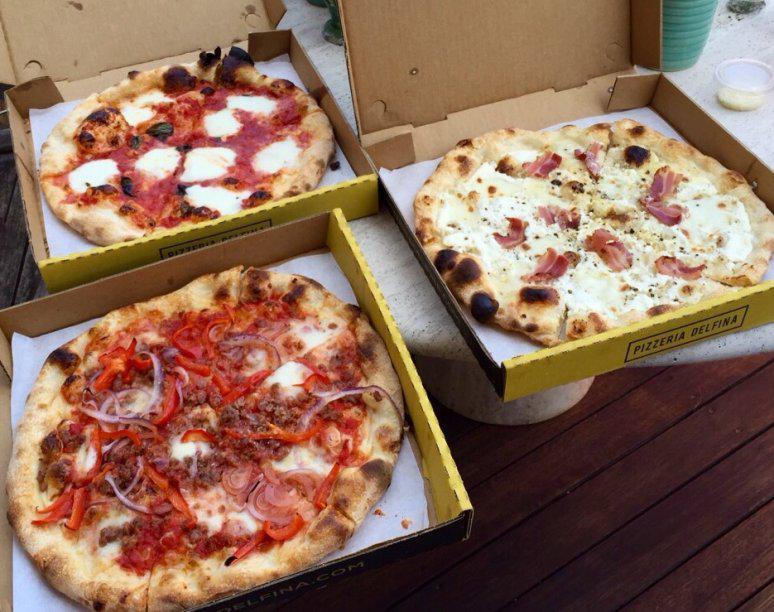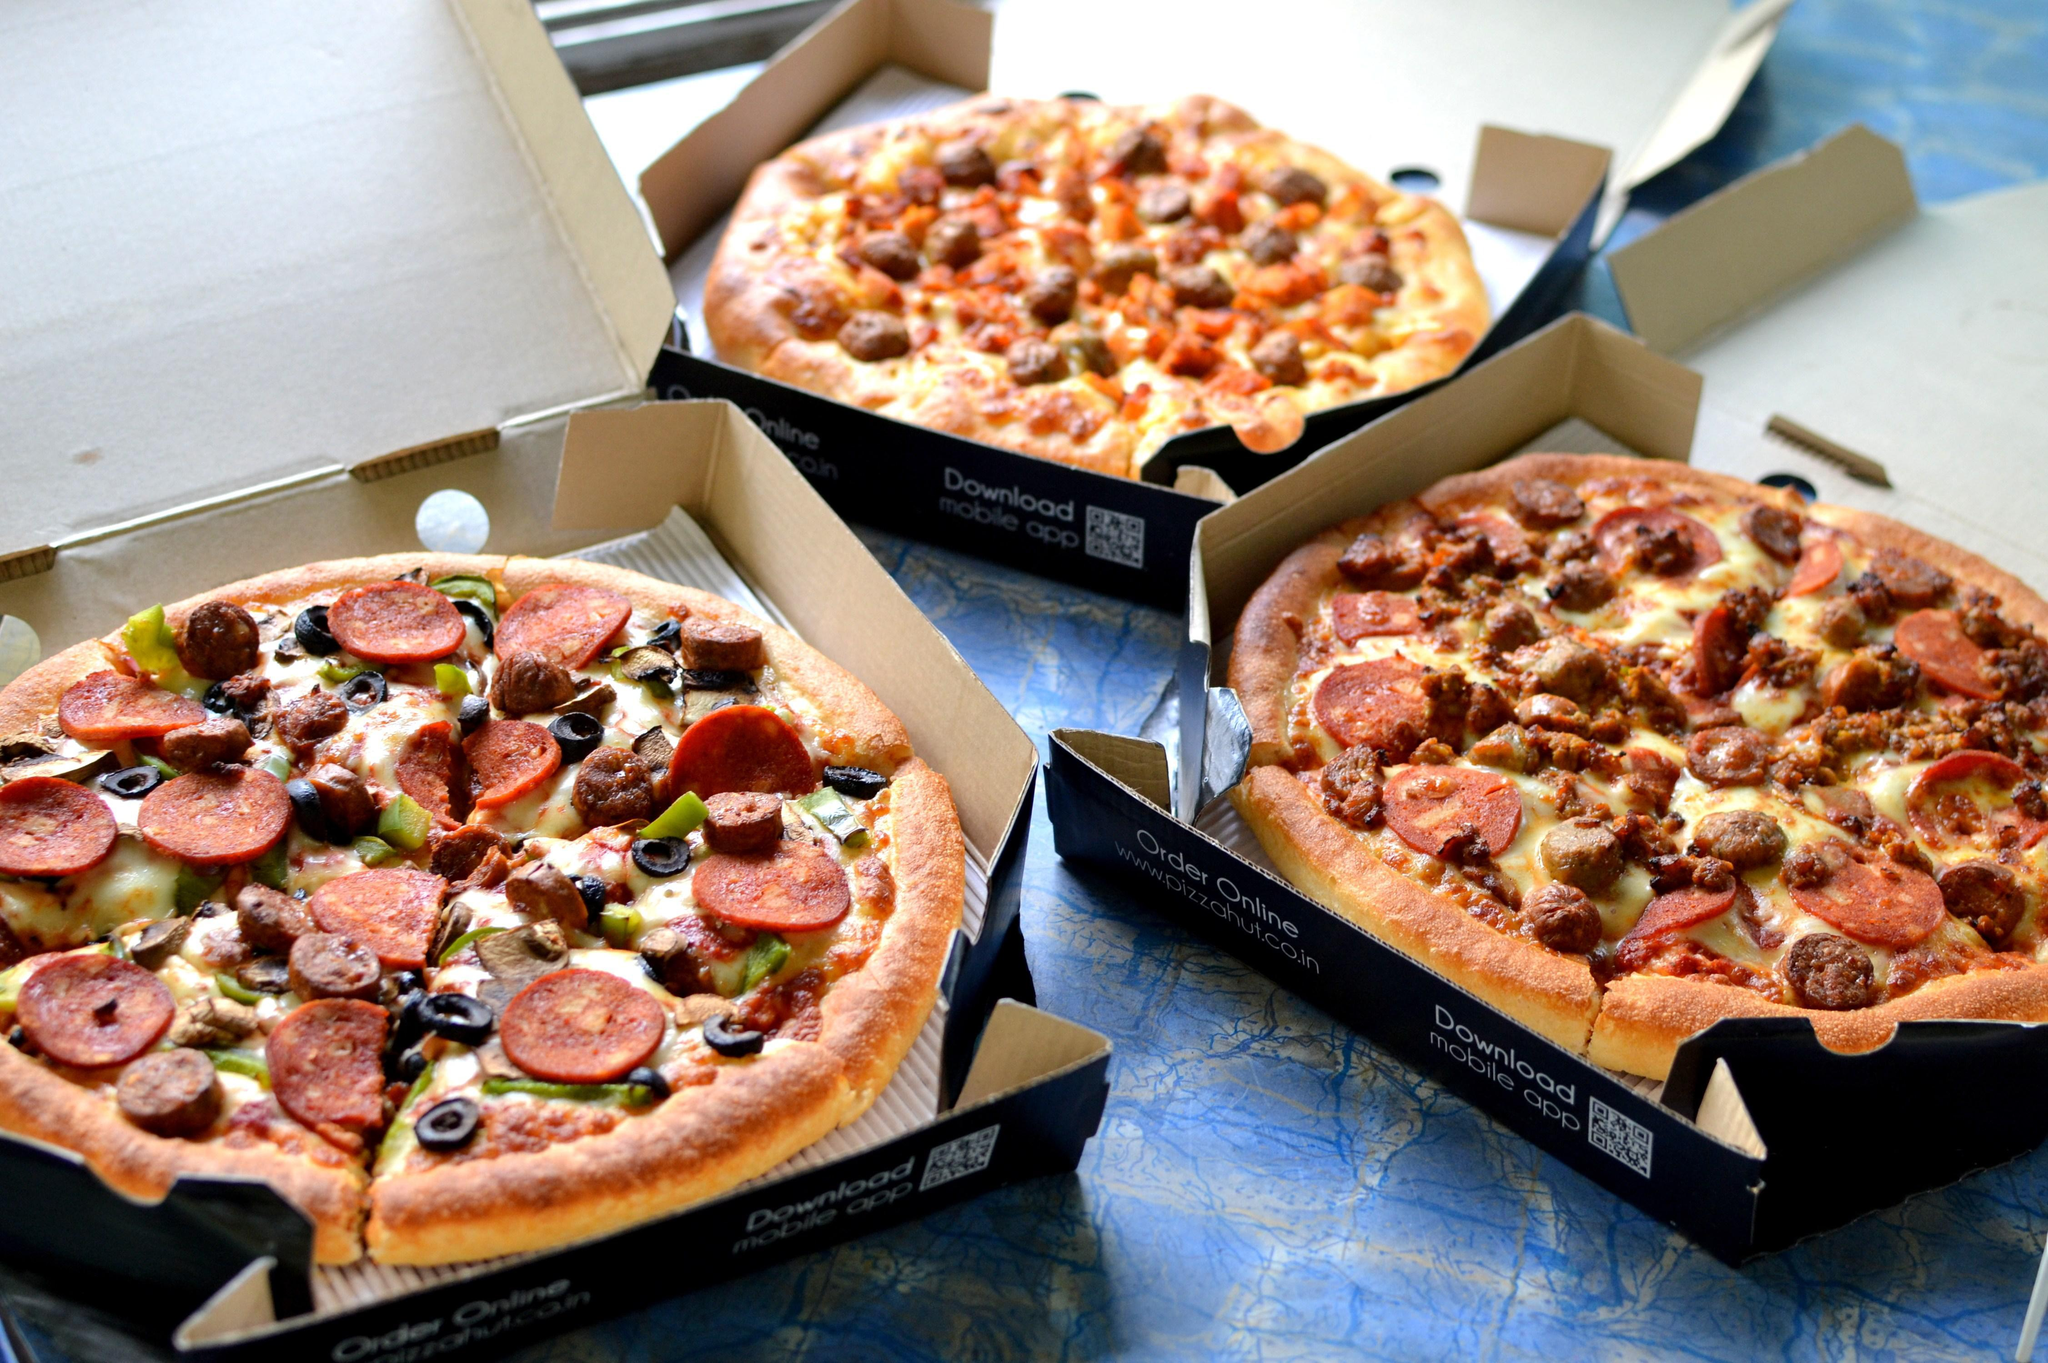The first image is the image on the left, the second image is the image on the right. Assess this claim about the two images: "There are exactly two pizzas.". Correct or not? Answer yes or no. No. The first image is the image on the left, the second image is the image on the right. Assess this claim about the two images: "There are no more than 2 pizzas.". Correct or not? Answer yes or no. No. 